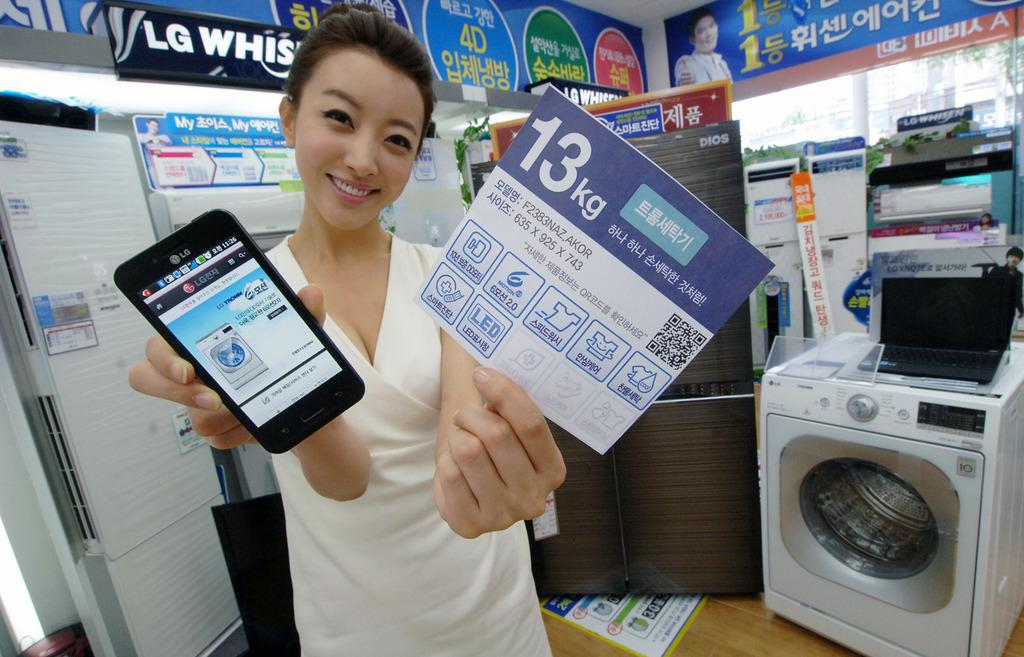<image>
Provide a brief description of the given image. a lady holding a paper with 13 on it 